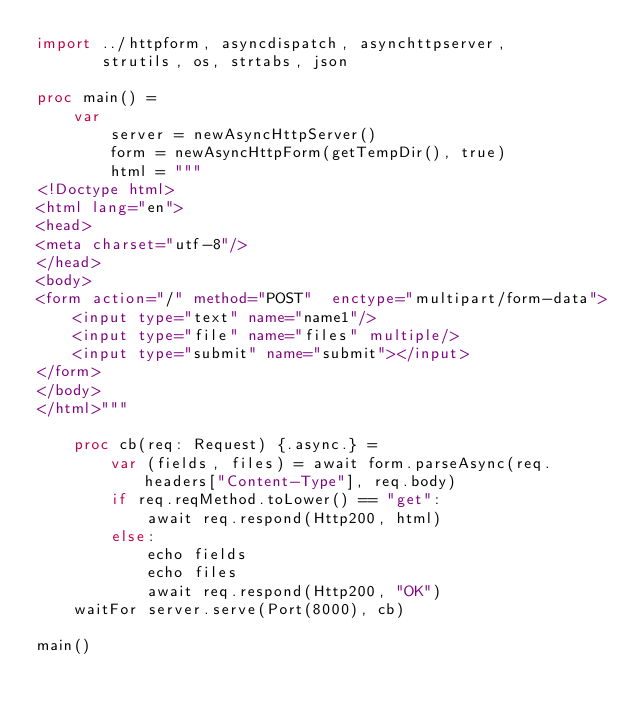Convert code to text. <code><loc_0><loc_0><loc_500><loc_500><_Nim_>import ../httpform, asyncdispatch, asynchttpserver,
       strutils, os, strtabs, json

proc main() =
    var
        server = newAsyncHttpServer()
        form = newAsyncHttpForm(getTempDir(), true)
        html = """
<!Doctype html>
<html lang="en">
<head>
<meta charset="utf-8"/>
</head>
<body>
<form action="/" method="POST"  enctype="multipart/form-data">
    <input type="text" name="name1"/>
    <input type="file" name="files" multiple/>
    <input type="submit" name="submit"></input>
</form>
</body>
</html>"""

    proc cb(req: Request) {.async.} =
        var (fields, files) = await form.parseAsync(req.headers["Content-Type"], req.body)
        if req.reqMethod.toLower() == "get":
            await req.respond(Http200, html)
        else:
            echo fields
            echo files
            await req.respond(Http200, "OK")
    waitFor server.serve(Port(8000), cb)

main()</code> 